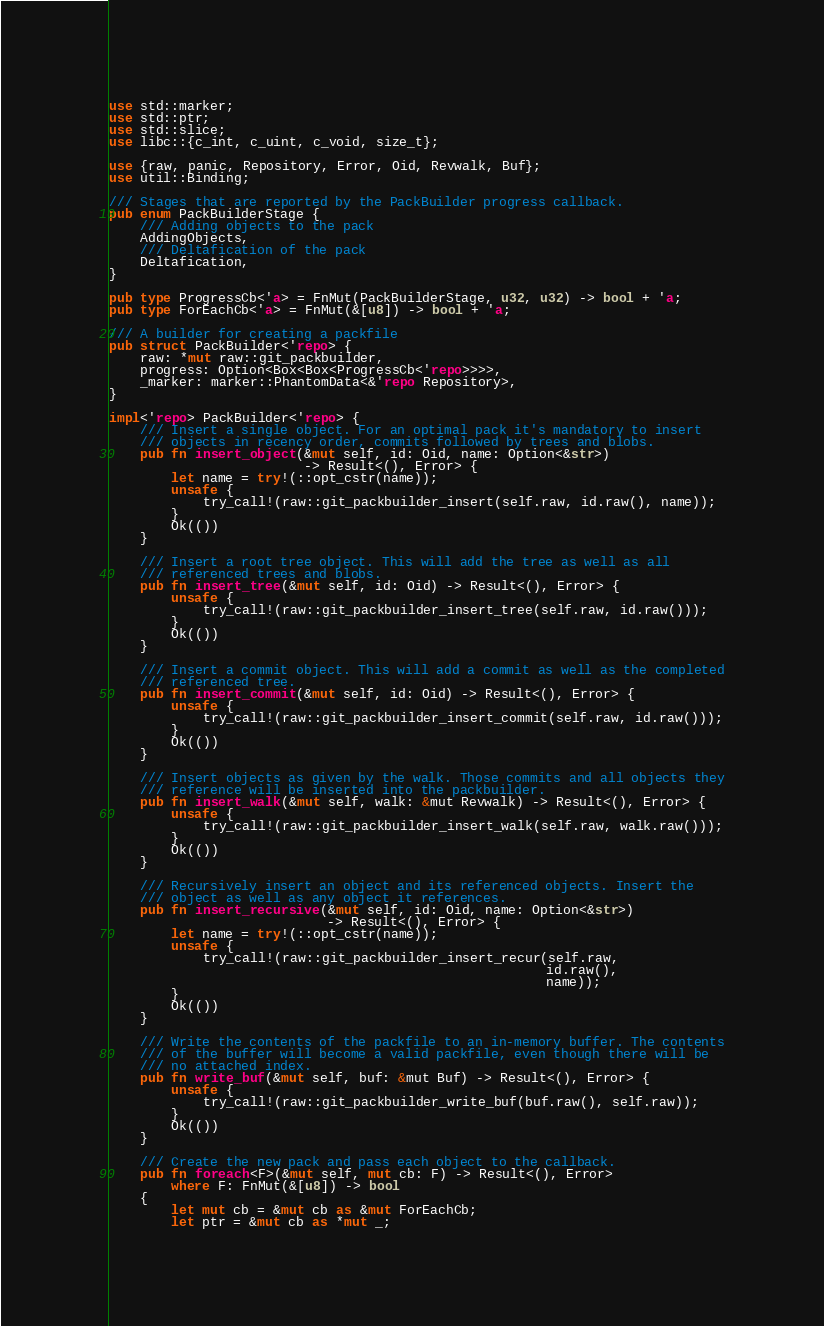Convert code to text. <code><loc_0><loc_0><loc_500><loc_500><_Rust_>use std::marker;
use std::ptr;
use std::slice;
use libc::{c_int, c_uint, c_void, size_t};

use {raw, panic, Repository, Error, Oid, Revwalk, Buf};
use util::Binding;

/// Stages that are reported by the PackBuilder progress callback.
pub enum PackBuilderStage {
    /// Adding objects to the pack
    AddingObjects,
    /// Deltafication of the pack
    Deltafication,
}

pub type ProgressCb<'a> = FnMut(PackBuilderStage, u32, u32) -> bool + 'a;
pub type ForEachCb<'a> = FnMut(&[u8]) -> bool + 'a;

/// A builder for creating a packfile
pub struct PackBuilder<'repo> {
    raw: *mut raw::git_packbuilder,
    progress: Option<Box<Box<ProgressCb<'repo>>>>,
    _marker: marker::PhantomData<&'repo Repository>,
}

impl<'repo> PackBuilder<'repo> {
    /// Insert a single object. For an optimal pack it's mandatory to insert
    /// objects in recency order, commits followed by trees and blobs.
    pub fn insert_object(&mut self, id: Oid, name: Option<&str>)
                         -> Result<(), Error> {
        let name = try!(::opt_cstr(name));
        unsafe {
            try_call!(raw::git_packbuilder_insert(self.raw, id.raw(), name));
        }
        Ok(())
    }

    /// Insert a root tree object. This will add the tree as well as all
    /// referenced trees and blobs.
    pub fn insert_tree(&mut self, id: Oid) -> Result<(), Error> {
        unsafe {
            try_call!(raw::git_packbuilder_insert_tree(self.raw, id.raw()));
        }
        Ok(())
    }

    /// Insert a commit object. This will add a commit as well as the completed
    /// referenced tree.
    pub fn insert_commit(&mut self, id: Oid) -> Result<(), Error> {
        unsafe {
            try_call!(raw::git_packbuilder_insert_commit(self.raw, id.raw()));
        }
        Ok(())
    }

    /// Insert objects as given by the walk. Those commits and all objects they
    /// reference will be inserted into the packbuilder.
    pub fn insert_walk(&mut self, walk: &mut Revwalk) -> Result<(), Error> {
        unsafe {
            try_call!(raw::git_packbuilder_insert_walk(self.raw, walk.raw()));
        }
        Ok(())
    }

    /// Recursively insert an object and its referenced objects. Insert the
    /// object as well as any object it references.
    pub fn insert_recursive(&mut self, id: Oid, name: Option<&str>)
                            -> Result<(), Error> {
        let name = try!(::opt_cstr(name));
        unsafe {
            try_call!(raw::git_packbuilder_insert_recur(self.raw,
                                                        id.raw(),
                                                        name));
        }
        Ok(())
    }

    /// Write the contents of the packfile to an in-memory buffer. The contents
    /// of the buffer will become a valid packfile, even though there will be
    /// no attached index.
    pub fn write_buf(&mut self, buf: &mut Buf) -> Result<(), Error> {
        unsafe {
            try_call!(raw::git_packbuilder_write_buf(buf.raw(), self.raw));
        }
        Ok(())
    }

    /// Create the new pack and pass each object to the callback.
    pub fn foreach<F>(&mut self, mut cb: F) -> Result<(), Error>
        where F: FnMut(&[u8]) -> bool
    {
        let mut cb = &mut cb as &mut ForEachCb;
        let ptr = &mut cb as *mut _;</code> 